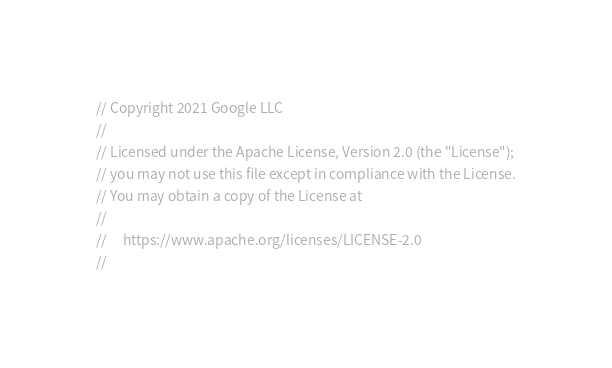Convert code to text. <code><loc_0><loc_0><loc_500><loc_500><_Go_>// Copyright 2021 Google LLC
//
// Licensed under the Apache License, Version 2.0 (the "License");
// you may not use this file except in compliance with the License.
// You may obtain a copy of the License at
//
//     https://www.apache.org/licenses/LICENSE-2.0
//</code> 